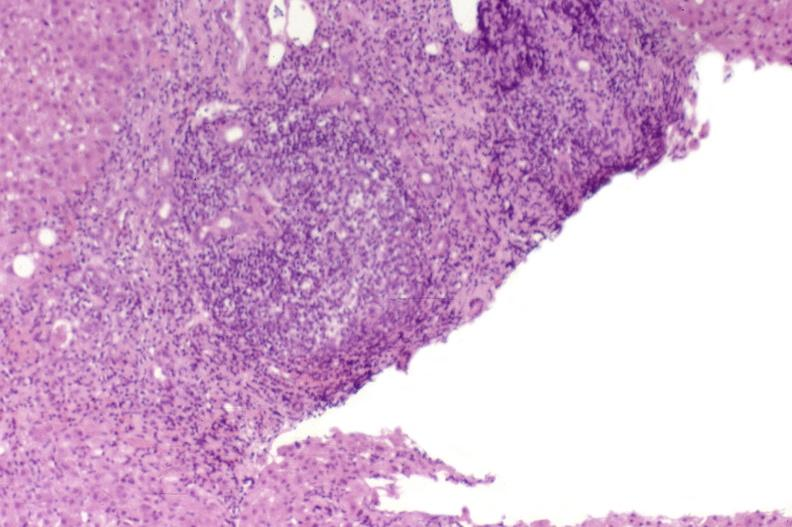s fat necrosis present?
Answer the question using a single word or phrase. No 